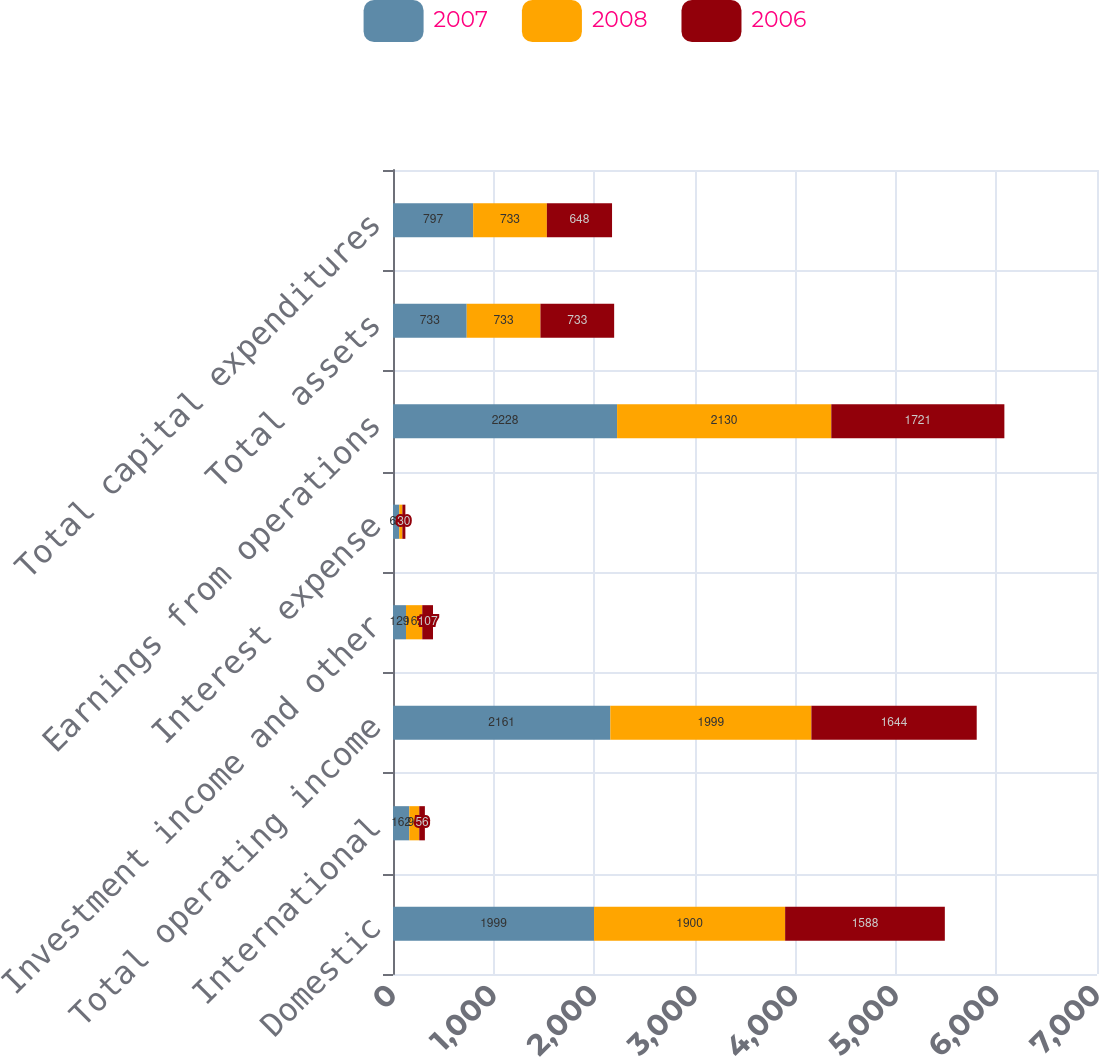Convert chart to OTSL. <chart><loc_0><loc_0><loc_500><loc_500><stacked_bar_chart><ecel><fcel>Domestic<fcel>International<fcel>Total operating income<fcel>Investment income and other<fcel>Interest expense<fcel>Earnings from operations<fcel>Total assets<fcel>Total capital expenditures<nl><fcel>2007<fcel>1999<fcel>162<fcel>2161<fcel>129<fcel>62<fcel>2228<fcel>733<fcel>797<nl><fcel>2008<fcel>1900<fcel>99<fcel>1999<fcel>162<fcel>31<fcel>2130<fcel>733<fcel>733<nl><fcel>2006<fcel>1588<fcel>56<fcel>1644<fcel>107<fcel>30<fcel>1721<fcel>733<fcel>648<nl></chart> 